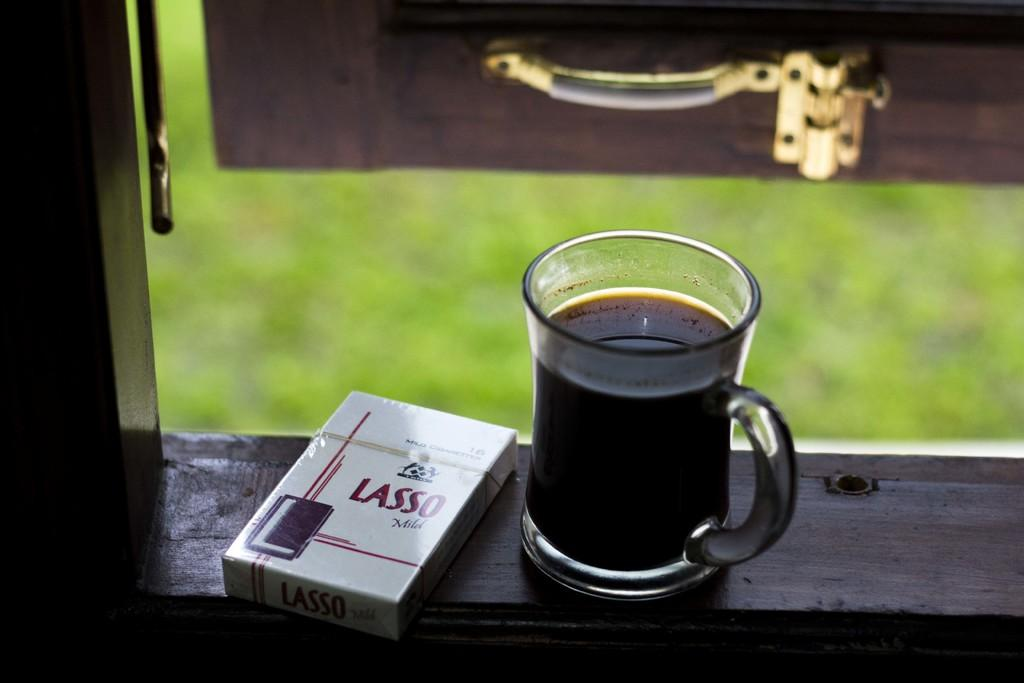What is in the cup that is visible in the image? There is a drink in the cup that is visible in the image. What is located beside the cup? There is a box beside the cup. Where are the cup and the box placed? Both the cup and the box are placed on a wooden platform. What type of vegetation can be seen in the background of the image? There is grass visible in the background of the image. What can be seen in the background of the image that is not vegetation? There is a handle in the background of the image. What type of cushion is being used by the group in the image? There is no group or cushion present in the image. 